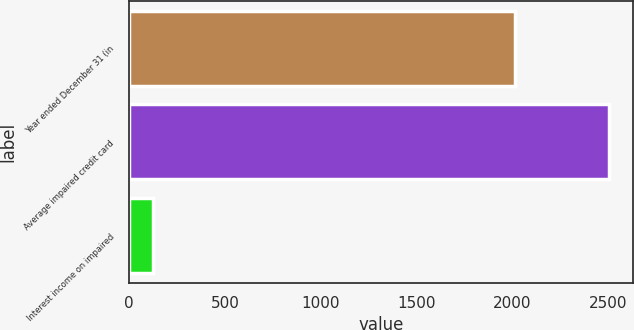<chart> <loc_0><loc_0><loc_500><loc_500><bar_chart><fcel>Year ended December 31 (in<fcel>Average impaired credit card<fcel>Interest income on impaired<nl><fcel>2014<fcel>2503<fcel>123<nl></chart> 